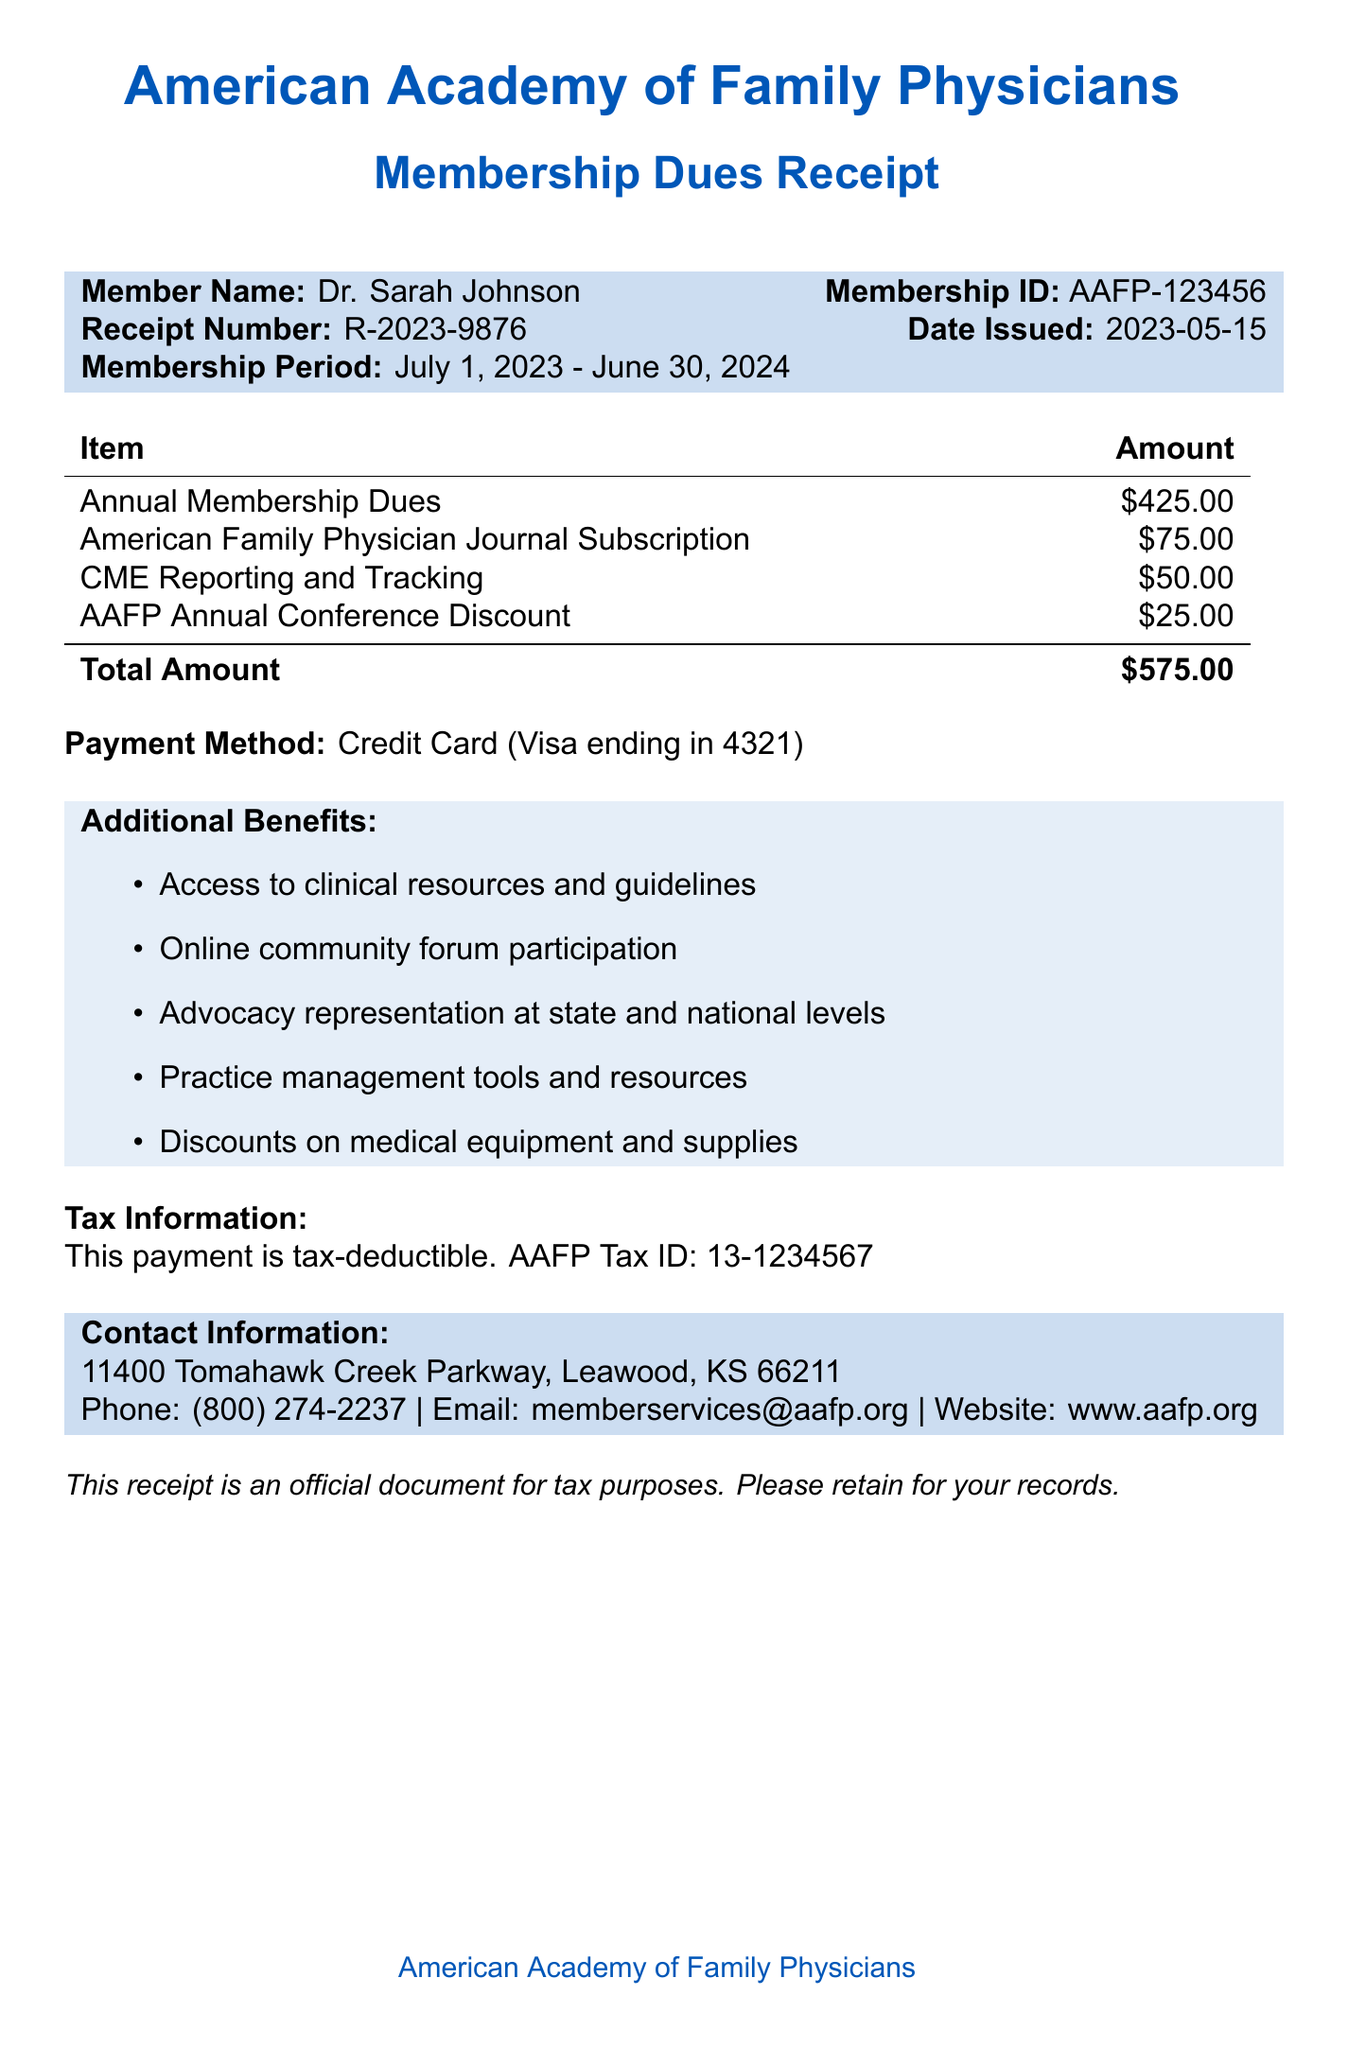What is the organization name? The organization name is listed at the top of the document, which is the American Academy of Family Physicians.
Answer: American Academy of Family Physicians Who is the member? The document specifies the name of the member who received the receipt, which is Dr. Sarah Johnson.
Answer: Dr. Sarah Johnson What is the membership period? The membership period indicates the valid dates for membership, which are explicitly provided in the document.
Answer: July 1, 2023 - June 30, 2024 What is the total amount paid? The total amount is specified in the document, combining all individual benefits.
Answer: $575.00 What benefits are included in the membership? To answer this, one can refer to the itemized list of benefits provided in the document.
Answer: Annual Membership Dues, American Family Physician Journal Subscription, CME Reporting and Tracking, AAFP Annual Conference Discount Is the payment tax-deductible? This information can be found in the tax information section of the document.
Answer: Yes What is the tax ID number? The tax ID number is provided in the tax information section of the document for reference.
Answer: 13-1234567 What payment method was used? The document specifies the method of payment utilized for membership dues.
Answer: Credit Card (Visa ending in 4321) What contact number is provided? The contact number can be found in the contact information section of the document.
Answer: (800) 274-2237 